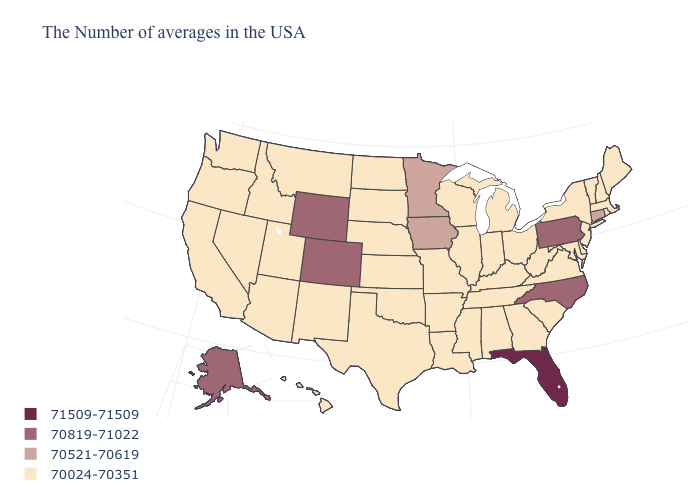Does the map have missing data?
Write a very short answer. No. Is the legend a continuous bar?
Quick response, please. No. What is the value of Alabama?
Keep it brief. 70024-70351. Is the legend a continuous bar?
Short answer required. No. Which states have the lowest value in the West?
Answer briefly. New Mexico, Utah, Montana, Arizona, Idaho, Nevada, California, Washington, Oregon, Hawaii. What is the value of Maine?
Short answer required. 70024-70351. Name the states that have a value in the range 70024-70351?
Answer briefly. Maine, Massachusetts, Rhode Island, New Hampshire, Vermont, New York, New Jersey, Delaware, Maryland, Virginia, South Carolina, West Virginia, Ohio, Georgia, Michigan, Kentucky, Indiana, Alabama, Tennessee, Wisconsin, Illinois, Mississippi, Louisiana, Missouri, Arkansas, Kansas, Nebraska, Oklahoma, Texas, South Dakota, North Dakota, New Mexico, Utah, Montana, Arizona, Idaho, Nevada, California, Washington, Oregon, Hawaii. What is the value of Utah?
Answer briefly. 70024-70351. Name the states that have a value in the range 71509-71509?
Be succinct. Florida. What is the lowest value in the USA?
Answer briefly. 70024-70351. Is the legend a continuous bar?
Short answer required. No. Which states have the lowest value in the South?
Concise answer only. Delaware, Maryland, Virginia, South Carolina, West Virginia, Georgia, Kentucky, Alabama, Tennessee, Mississippi, Louisiana, Arkansas, Oklahoma, Texas. Which states have the lowest value in the USA?
Write a very short answer. Maine, Massachusetts, Rhode Island, New Hampshire, Vermont, New York, New Jersey, Delaware, Maryland, Virginia, South Carolina, West Virginia, Ohio, Georgia, Michigan, Kentucky, Indiana, Alabama, Tennessee, Wisconsin, Illinois, Mississippi, Louisiana, Missouri, Arkansas, Kansas, Nebraska, Oklahoma, Texas, South Dakota, North Dakota, New Mexico, Utah, Montana, Arizona, Idaho, Nevada, California, Washington, Oregon, Hawaii. Does Hawaii have a lower value than Utah?
Be succinct. No. 